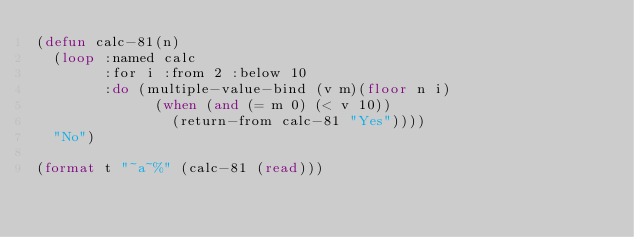<code> <loc_0><loc_0><loc_500><loc_500><_Lisp_>(defun calc-81(n)
  (loop :named calc
        :for i :from 2 :below 10
        :do (multiple-value-bind (v m)(floor n i)
              (when (and (= m 0) (< v 10))
                (return-from calc-81 "Yes"))))
  "No")

(format t "~a~%" (calc-81 (read)))</code> 